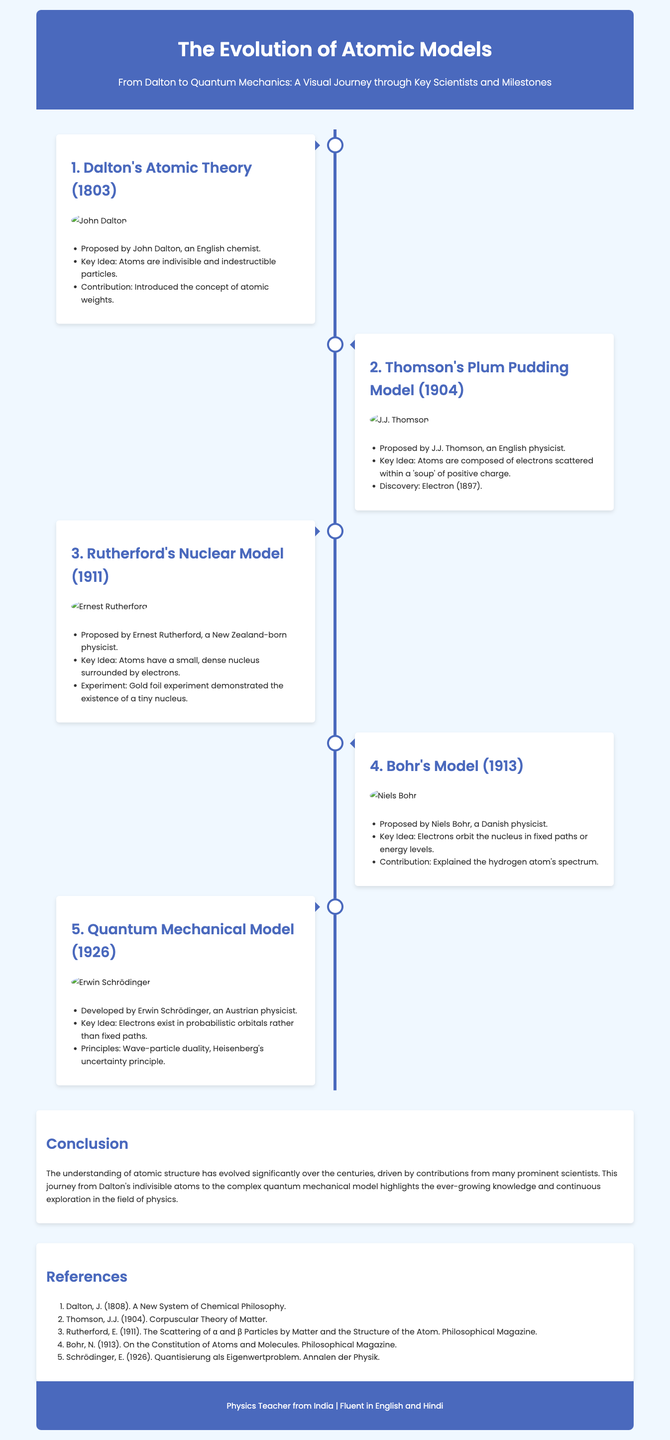What year was Dalton's Atomic Theory proposed? Dalton's Atomic Theory was proposed in 1803.
Answer: 1803 Who proposed the Plum Pudding Model? The Plum Pudding Model was proposed by J.J. Thomson.
Answer: J.J. Thomson What significant experiment did Rutherford conduct? Rutherford conducted the Gold foil experiment that demonstrated the existence of a tiny nucleus.
Answer: Gold foil experiment What is the key idea of the Quantum Mechanical Model? The key idea is that electrons exist in probabilistic orbitals rather than fixed paths.
Answer: Probabilistic orbitals Which scientist explained the hydrogen atom's spectrum? Niels Bohr explained the hydrogen atom's spectrum.
Answer: Niels Bohr What are the principles included in the Quantum Mechanical Model? The principles include wave-particle duality and Heisenberg's uncertainty principle.
Answer: Wave-particle duality, Heisenberg's uncertainty principle In what year did Schrödinger develop the Quantum Mechanical Model? Schrödinger developed the Quantum Mechanical Model in 1926.
Answer: 1926 What was the key idea in Thomson's model? The key idea is that atoms are composed of electrons scattered within a 'soup' of positive charge.
Answer: Electrons scattered within positive charge What notable contribution did Dalton make to atomic theory? Dalton introduced the concept of atomic weights.
Answer: Concept of atomic weights 